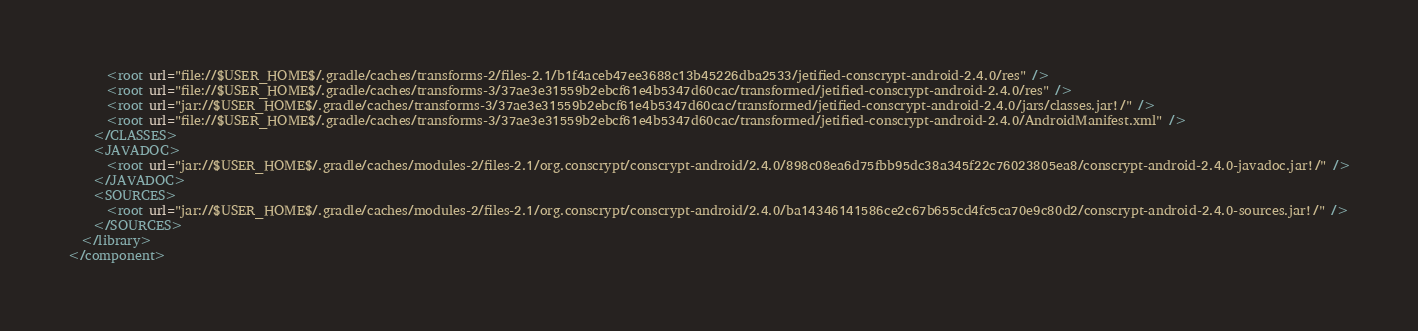Convert code to text. <code><loc_0><loc_0><loc_500><loc_500><_XML_>      <root url="file://$USER_HOME$/.gradle/caches/transforms-2/files-2.1/b1f4aceb47ee3688c13b45226dba2533/jetified-conscrypt-android-2.4.0/res" />
      <root url="file://$USER_HOME$/.gradle/caches/transforms-3/37ae3e31559b2ebcf61e4b5347d60cac/transformed/jetified-conscrypt-android-2.4.0/res" />
      <root url="jar://$USER_HOME$/.gradle/caches/transforms-3/37ae3e31559b2ebcf61e4b5347d60cac/transformed/jetified-conscrypt-android-2.4.0/jars/classes.jar!/" />
      <root url="file://$USER_HOME$/.gradle/caches/transforms-3/37ae3e31559b2ebcf61e4b5347d60cac/transformed/jetified-conscrypt-android-2.4.0/AndroidManifest.xml" />
    </CLASSES>
    <JAVADOC>
      <root url="jar://$USER_HOME$/.gradle/caches/modules-2/files-2.1/org.conscrypt/conscrypt-android/2.4.0/898c08ea6d75fbb95dc38a345f22c76023805ea8/conscrypt-android-2.4.0-javadoc.jar!/" />
    </JAVADOC>
    <SOURCES>
      <root url="jar://$USER_HOME$/.gradle/caches/modules-2/files-2.1/org.conscrypt/conscrypt-android/2.4.0/ba14346141586ce2c67b655cd4fc5ca70e9c80d2/conscrypt-android-2.4.0-sources.jar!/" />
    </SOURCES>
  </library>
</component></code> 